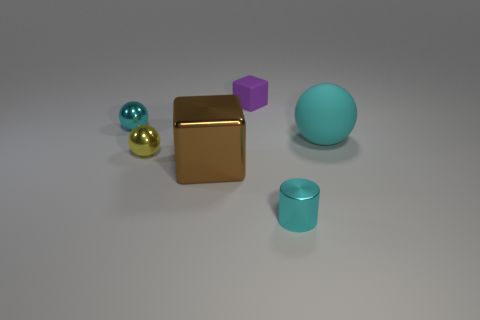The other big metal object that is the same shape as the purple object is what color?
Provide a short and direct response. Brown. Is there any other thing that is the same shape as the small rubber thing?
Ensure brevity in your answer.  Yes. Is the number of metallic spheres on the right side of the yellow thing the same as the number of cubes?
Offer a very short reply. No. What number of blocks are behind the cyan shiny ball and in front of the small yellow ball?
Make the answer very short. 0. What size is the matte object that is the same shape as the big brown shiny thing?
Your answer should be compact. Small. What number of large cyan objects are the same material as the cyan cylinder?
Offer a terse response. 0. Is the number of yellow objects that are behind the yellow ball less than the number of small cyan things?
Offer a terse response. Yes. What number of small cubes are there?
Give a very brief answer. 1. What number of cylinders are the same color as the matte sphere?
Your answer should be very brief. 1. Is the tiny rubber thing the same shape as the large cyan matte thing?
Offer a terse response. No. 